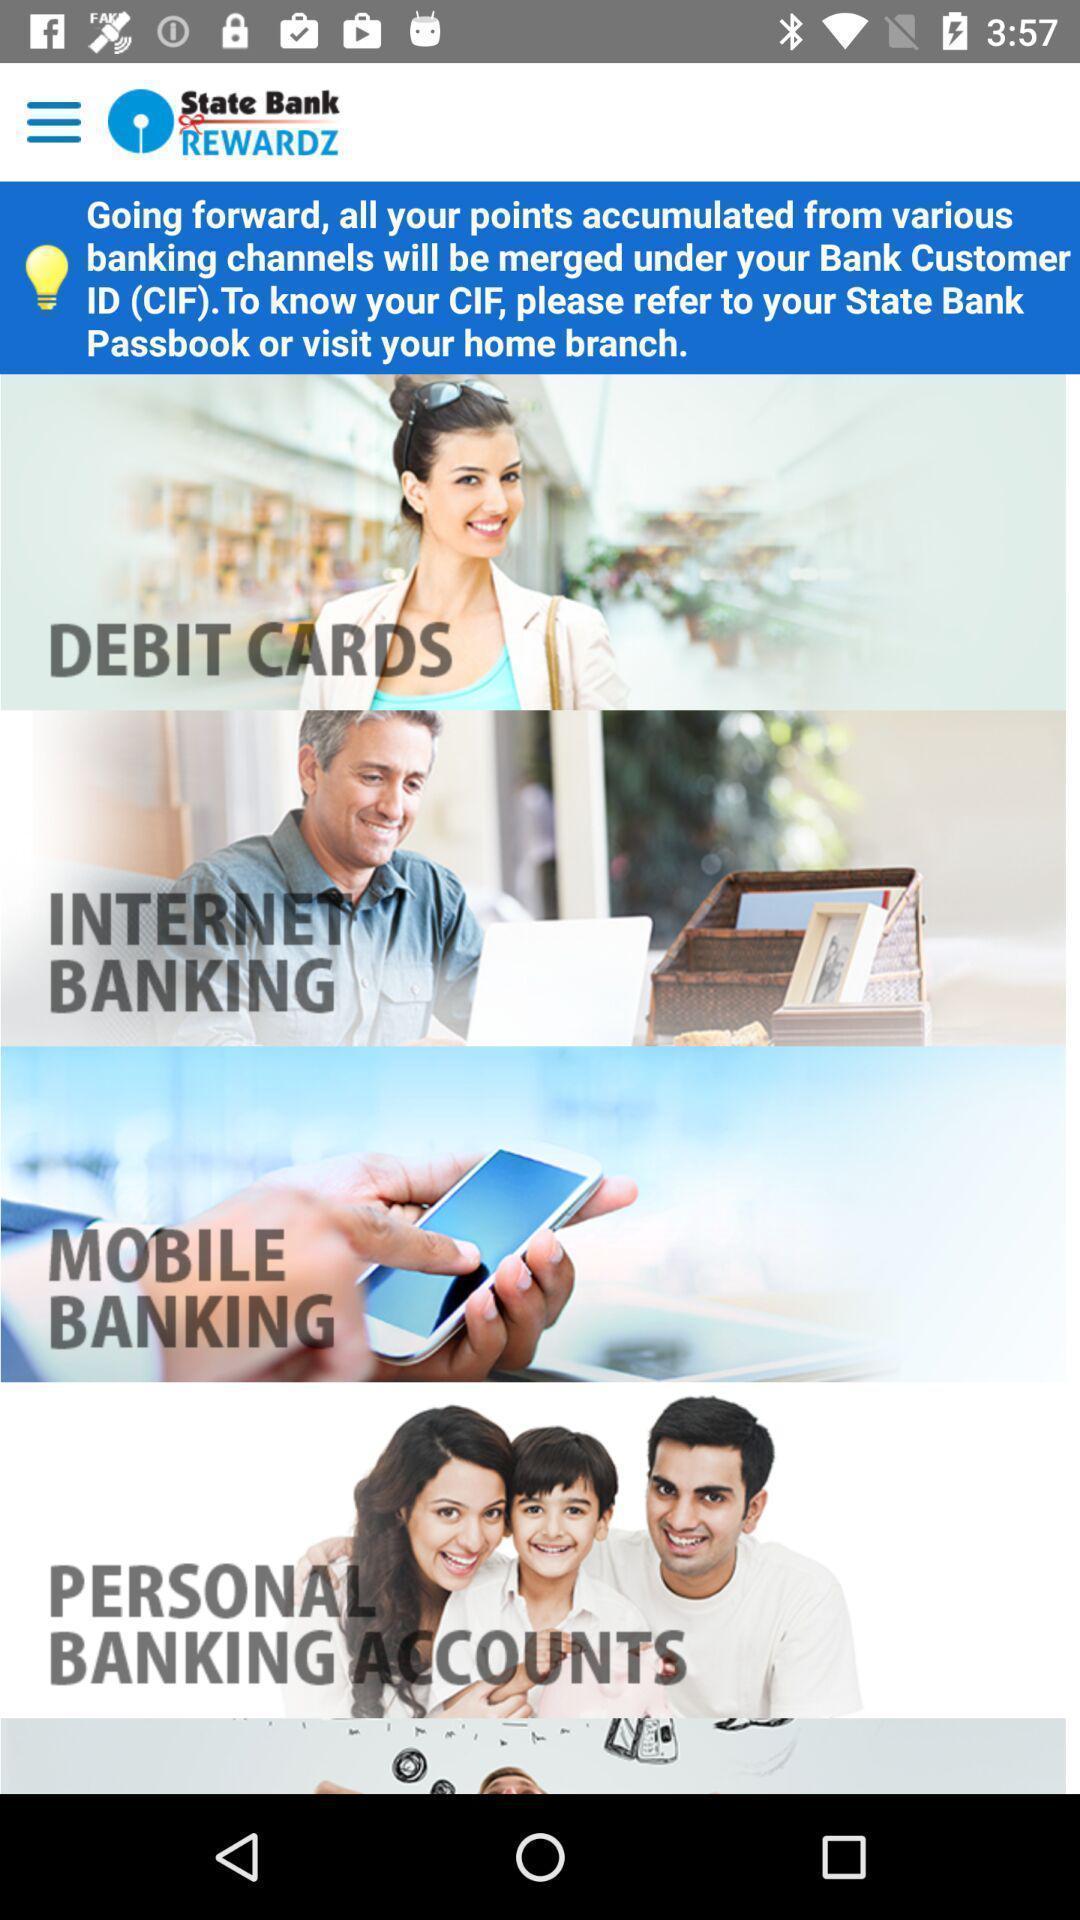Summarize the information in this screenshot. Screen displaying the various feature of a bank app. 